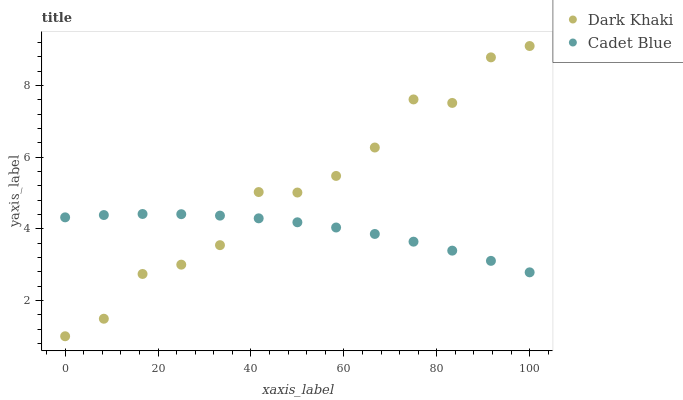Does Cadet Blue have the minimum area under the curve?
Answer yes or no. Yes. Does Dark Khaki have the maximum area under the curve?
Answer yes or no. Yes. Does Cadet Blue have the maximum area under the curve?
Answer yes or no. No. Is Cadet Blue the smoothest?
Answer yes or no. Yes. Is Dark Khaki the roughest?
Answer yes or no. Yes. Is Cadet Blue the roughest?
Answer yes or no. No. Does Dark Khaki have the lowest value?
Answer yes or no. Yes. Does Cadet Blue have the lowest value?
Answer yes or no. No. Does Dark Khaki have the highest value?
Answer yes or no. Yes. Does Cadet Blue have the highest value?
Answer yes or no. No. Does Dark Khaki intersect Cadet Blue?
Answer yes or no. Yes. Is Dark Khaki less than Cadet Blue?
Answer yes or no. No. Is Dark Khaki greater than Cadet Blue?
Answer yes or no. No. 